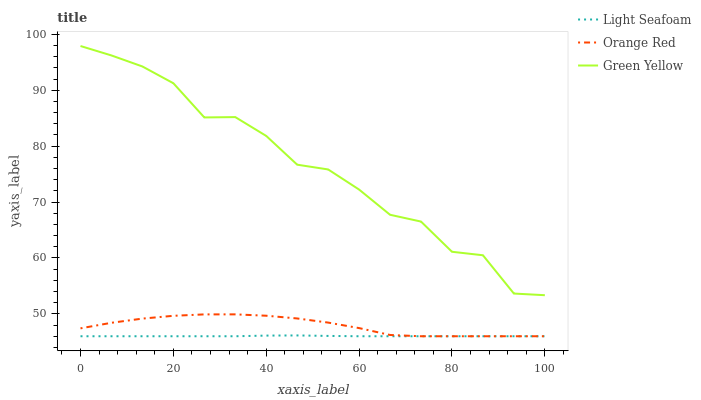Does Light Seafoam have the minimum area under the curve?
Answer yes or no. Yes. Does Green Yellow have the maximum area under the curve?
Answer yes or no. Yes. Does Orange Red have the minimum area under the curve?
Answer yes or no. No. Does Orange Red have the maximum area under the curve?
Answer yes or no. No. Is Light Seafoam the smoothest?
Answer yes or no. Yes. Is Green Yellow the roughest?
Answer yes or no. Yes. Is Orange Red the smoothest?
Answer yes or no. No. Is Orange Red the roughest?
Answer yes or no. No. Does Green Yellow have the highest value?
Answer yes or no. Yes. Does Orange Red have the highest value?
Answer yes or no. No. Is Orange Red less than Green Yellow?
Answer yes or no. Yes. Is Green Yellow greater than Orange Red?
Answer yes or no. Yes. Does Orange Red intersect Green Yellow?
Answer yes or no. No. 